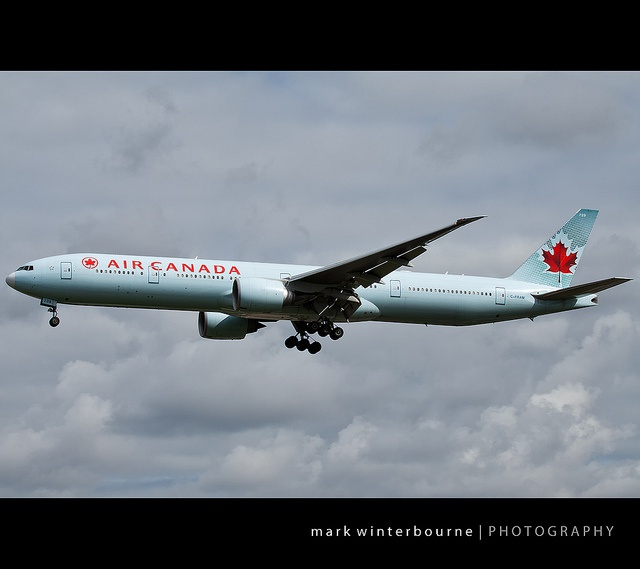Describe the objects in this image and their specific colors. I can see a airplane in black, lightgray, darkgray, and lightblue tones in this image. 